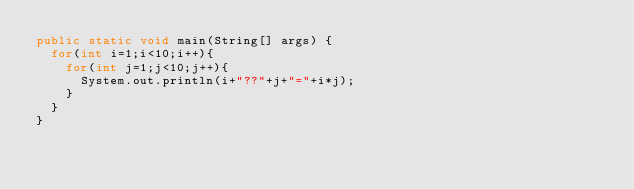<code> <loc_0><loc_0><loc_500><loc_500><_Java_>public static void main(String[] args) {
	for(int i=1;i<10;i++){
		for(int j=1;j<10;j++){
			System.out.println(i+"??"+j+"="+i*j);
		}
	}
}</code> 